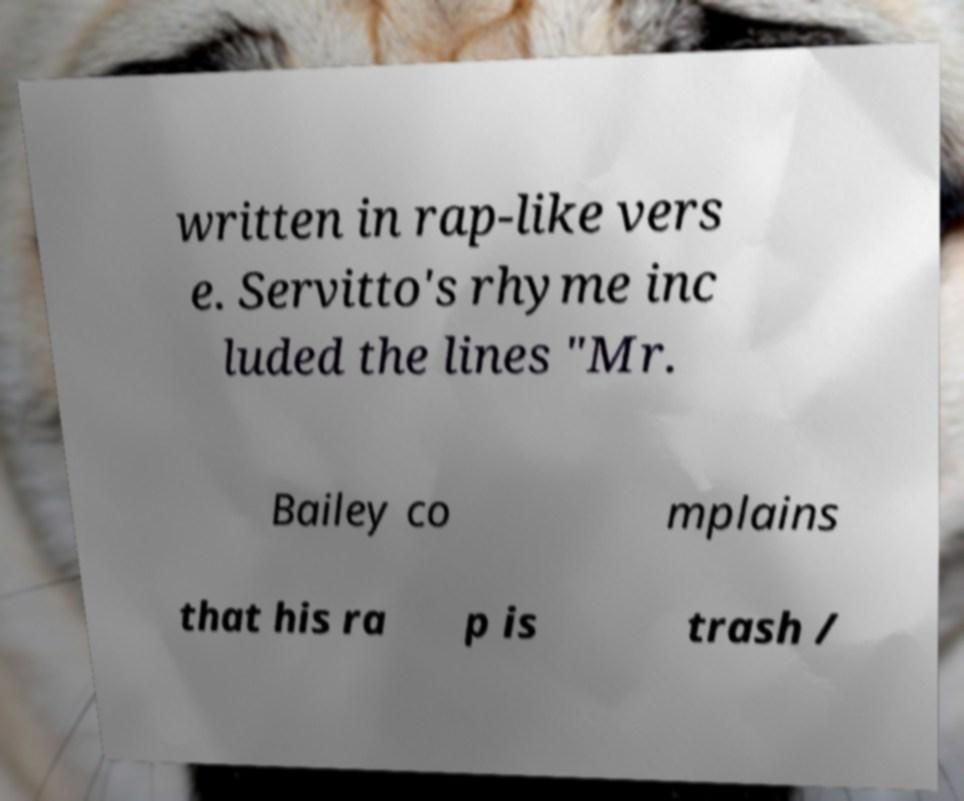Could you extract and type out the text from this image? written in rap-like vers e. Servitto's rhyme inc luded the lines "Mr. Bailey co mplains that his ra p is trash / 